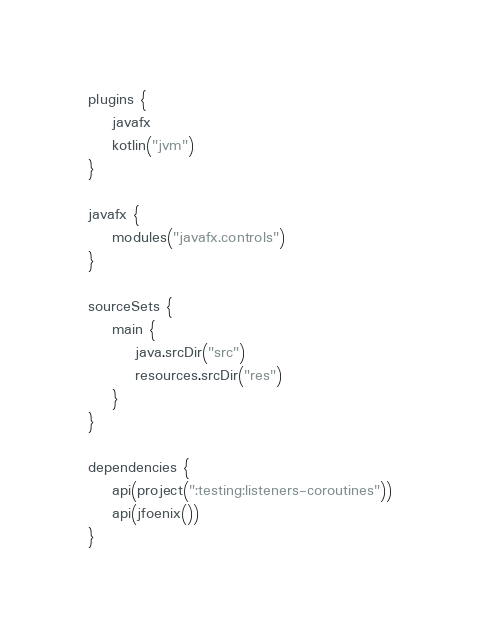<code> <loc_0><loc_0><loc_500><loc_500><_Kotlin_>plugins {
    javafx
    kotlin("jvm")
}

javafx {
    modules("javafx.controls")
}

sourceSets {
    main {
        java.srcDir("src")
        resources.srcDir("res")
    }
}

dependencies {
    api(project(":testing:listeners-coroutines"))
    api(jfoenix())
}</code> 